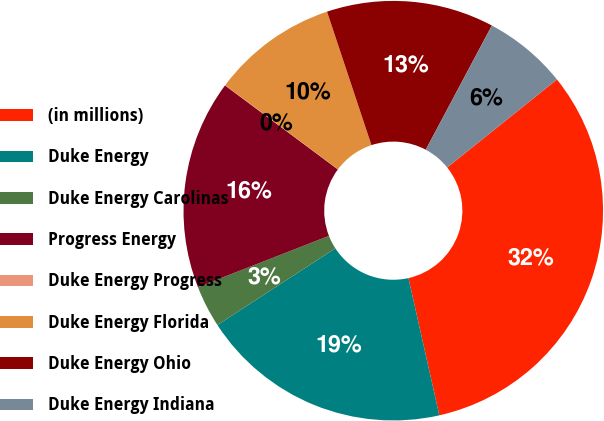Convert chart. <chart><loc_0><loc_0><loc_500><loc_500><pie_chart><fcel>(in millions)<fcel>Duke Energy<fcel>Duke Energy Carolinas<fcel>Progress Energy<fcel>Duke Energy Progress<fcel>Duke Energy Florida<fcel>Duke Energy Ohio<fcel>Duke Energy Indiana<nl><fcel>32.23%<fcel>19.35%<fcel>3.24%<fcel>16.12%<fcel>0.02%<fcel>9.68%<fcel>12.9%<fcel>6.46%<nl></chart> 